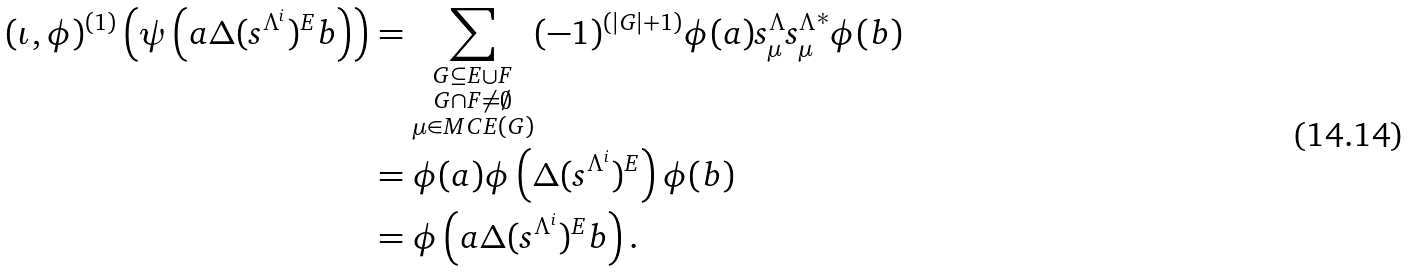<formula> <loc_0><loc_0><loc_500><loc_500>( \iota , \phi ) ^ { ( 1 ) } \left ( \psi \left ( a \Delta ( s ^ { \Lambda ^ { i } } ) ^ { E } b \right ) \right ) & = \sum _ { \substack { G \subseteq E \cup F \\ G \cap F \neq \emptyset \\ \mu \in M C E ( G ) } } ( - 1 ) ^ { ( | G | + 1 ) } \phi ( a ) s _ { \mu } ^ { \Lambda } { s _ { \mu } ^ { \Lambda } } ^ { * } \phi ( b ) \\ & = \phi ( a ) \phi \left ( \Delta ( s ^ { \Lambda ^ { i } } ) ^ { E } \right ) \phi ( b ) \\ & = \phi \left ( a \Delta ( s ^ { \Lambda ^ { i } } ) ^ { E } b \right ) .</formula> 